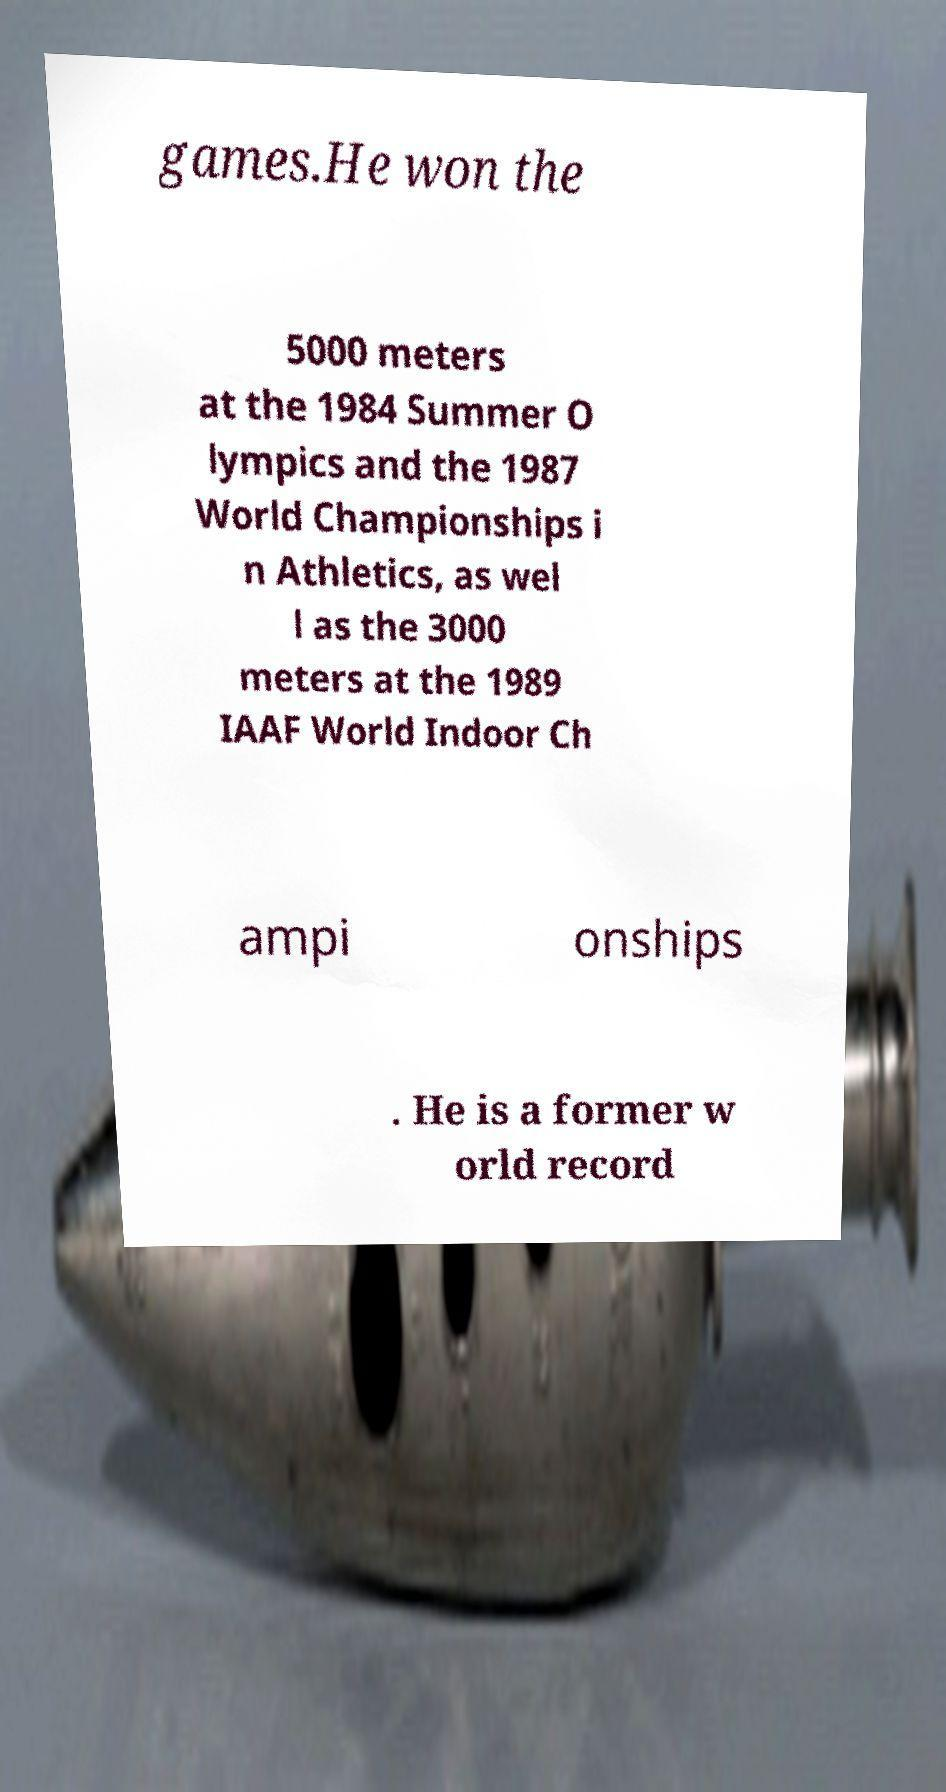Can you read and provide the text displayed in the image?This photo seems to have some interesting text. Can you extract and type it out for me? games.He won the 5000 meters at the 1984 Summer O lympics and the 1987 World Championships i n Athletics, as wel l as the 3000 meters at the 1989 IAAF World Indoor Ch ampi onships . He is a former w orld record 